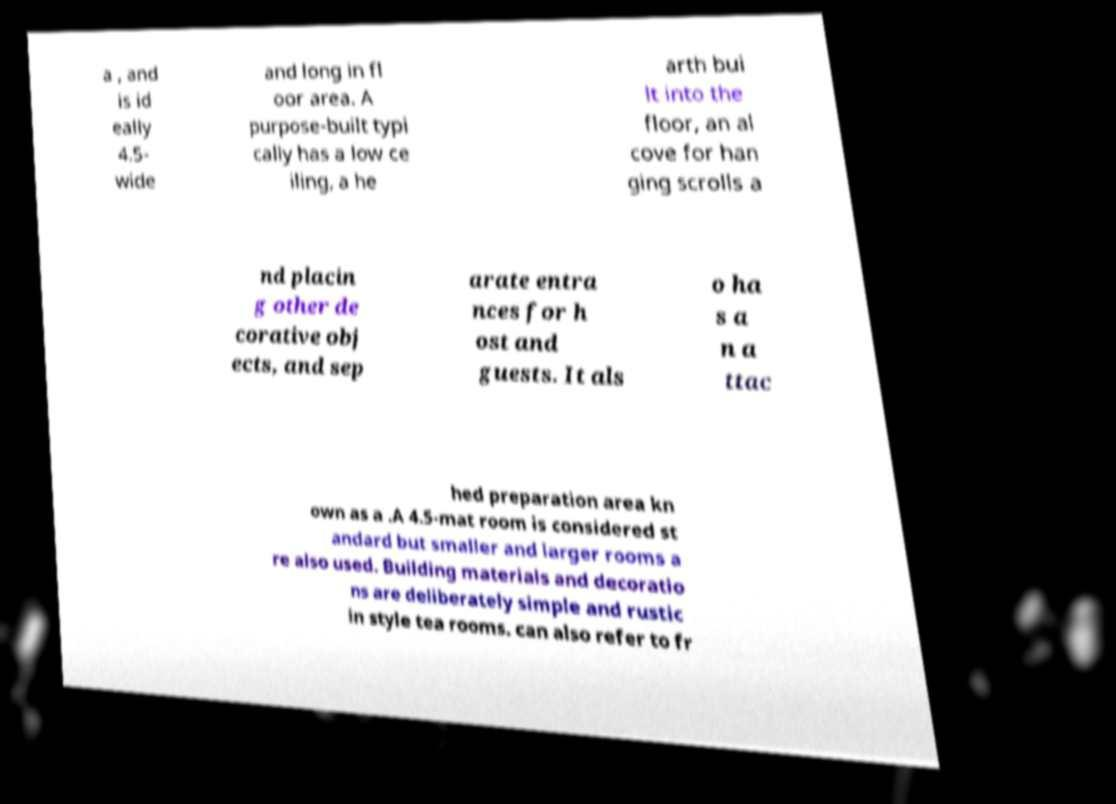I need the written content from this picture converted into text. Can you do that? a , and is id eally 4.5- wide and long in fl oor area. A purpose-built typi cally has a low ce iling, a he arth bui lt into the floor, an al cove for han ging scrolls a nd placin g other de corative obj ects, and sep arate entra nces for h ost and guests. It als o ha s a n a ttac hed preparation area kn own as a .A 4.5-mat room is considered st andard but smaller and larger rooms a re also used. Building materials and decoratio ns are deliberately simple and rustic in style tea rooms. can also refer to fr 